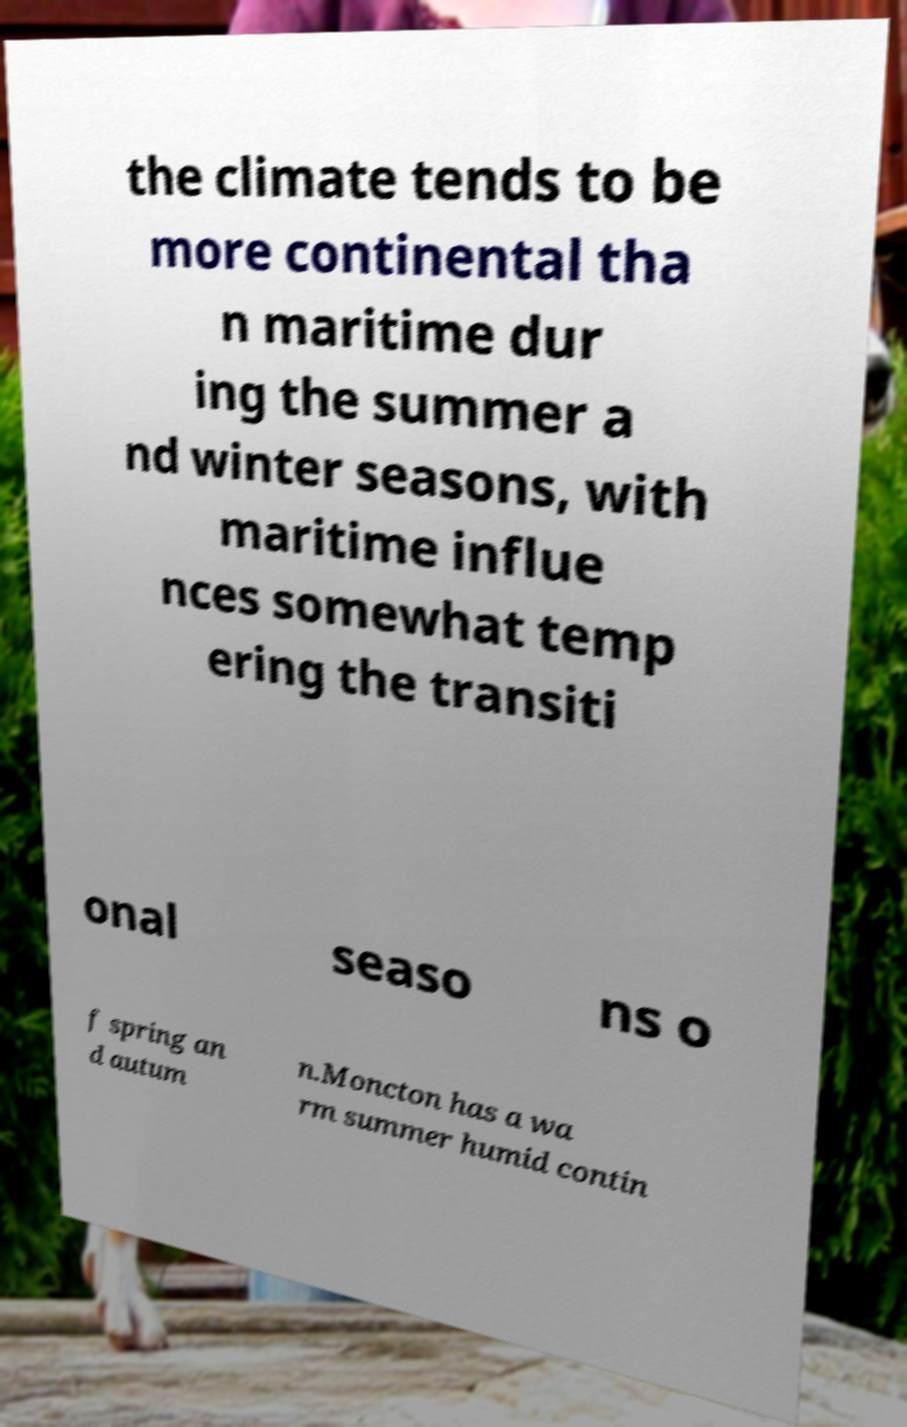For documentation purposes, I need the text within this image transcribed. Could you provide that? the climate tends to be more continental tha n maritime dur ing the summer a nd winter seasons, with maritime influe nces somewhat temp ering the transiti onal seaso ns o f spring an d autum n.Moncton has a wa rm summer humid contin 